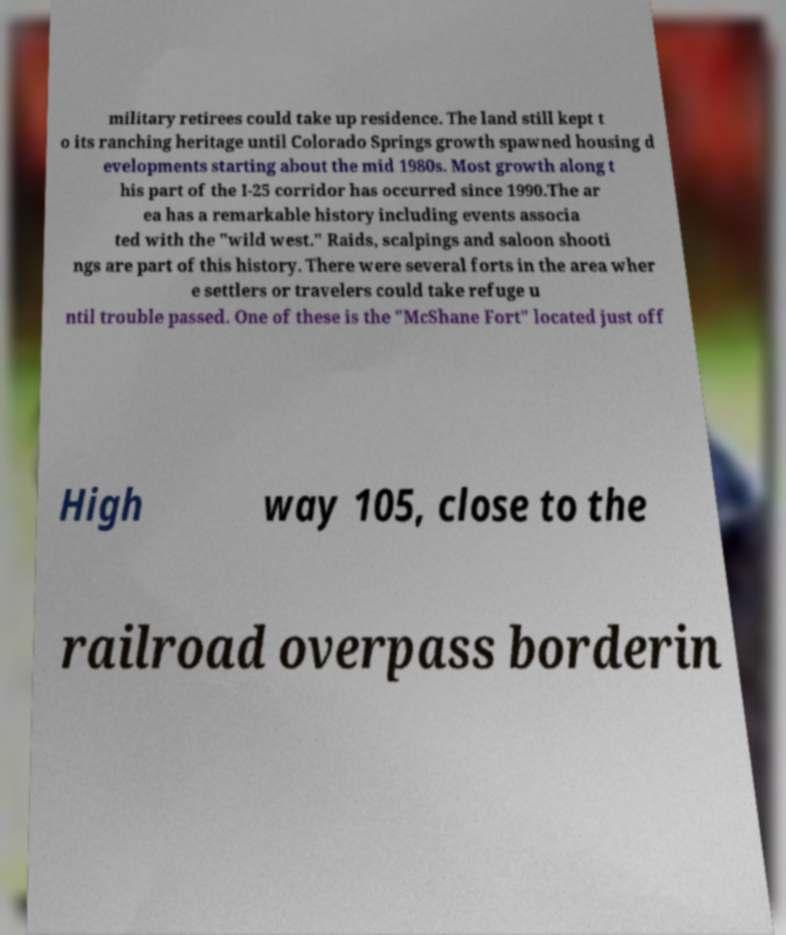What messages or text are displayed in this image? I need them in a readable, typed format. military retirees could take up residence. The land still kept t o its ranching heritage until Colorado Springs growth spawned housing d evelopments starting about the mid 1980s. Most growth along t his part of the I-25 corridor has occurred since 1990.The ar ea has a remarkable history including events associa ted with the "wild west." Raids, scalpings and saloon shooti ngs are part of this history. There were several forts in the area wher e settlers or travelers could take refuge u ntil trouble passed. One of these is the "McShane Fort" located just off High way 105, close to the railroad overpass borderin 